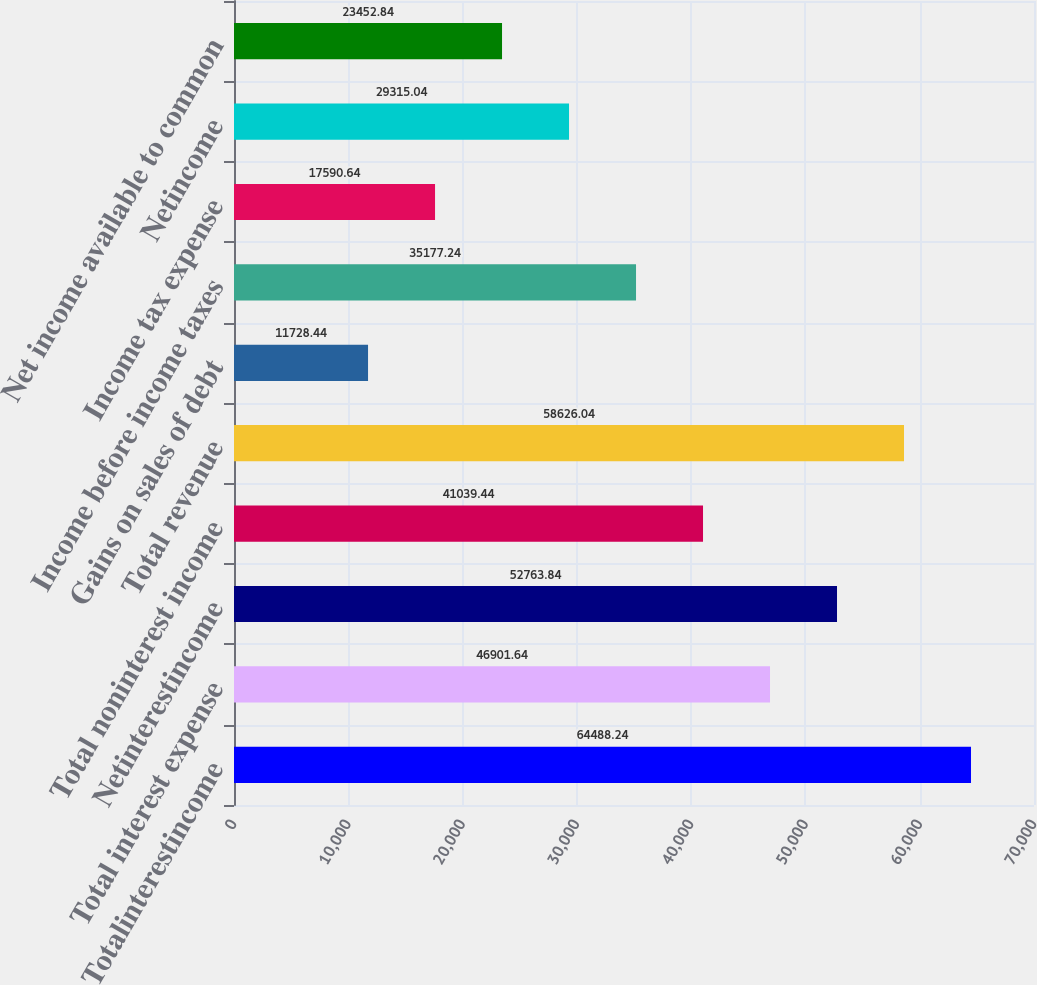<chart> <loc_0><loc_0><loc_500><loc_500><bar_chart><fcel>Totalinterestincome<fcel>Total interest expense<fcel>Netinterestincome<fcel>Total noninterest income<fcel>Total revenue<fcel>Gains on sales of debt<fcel>Income before income taxes<fcel>Income tax expense<fcel>Netincome<fcel>Net income available to common<nl><fcel>64488.2<fcel>46901.6<fcel>52763.8<fcel>41039.4<fcel>58626<fcel>11728.4<fcel>35177.2<fcel>17590.6<fcel>29315<fcel>23452.8<nl></chart> 